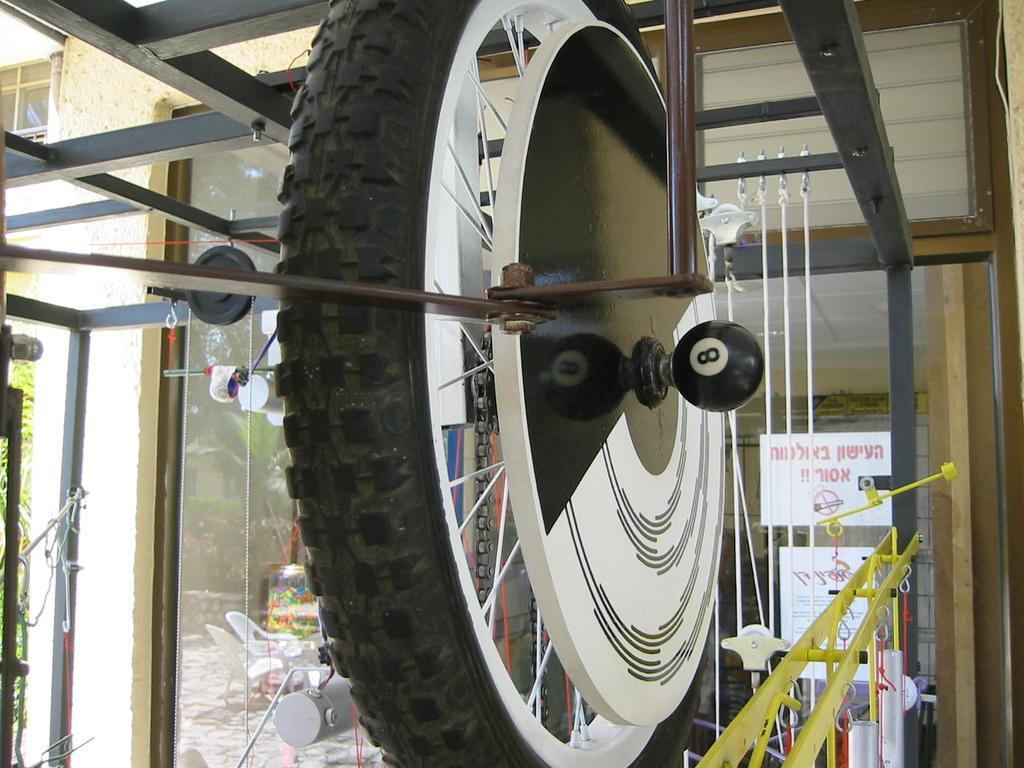Can you describe this image briefly? In this image there is a tyre in middle of this image. there are two chairs kept at bottom of this image which is in white color. There is a door at left side of this image and there are some trees in the background and there is a glass door at right side of this image. 